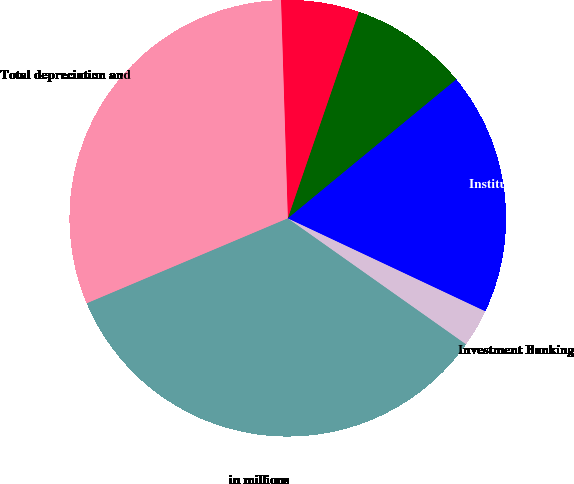<chart> <loc_0><loc_0><loc_500><loc_500><pie_chart><fcel>in millions<fcel>Investment Banking<fcel>Institutional Client Services<fcel>Investing & Lending<fcel>Investment Management<fcel>Total depreciation and<nl><fcel>33.85%<fcel>2.79%<fcel>17.98%<fcel>8.75%<fcel>5.77%<fcel>30.87%<nl></chart> 